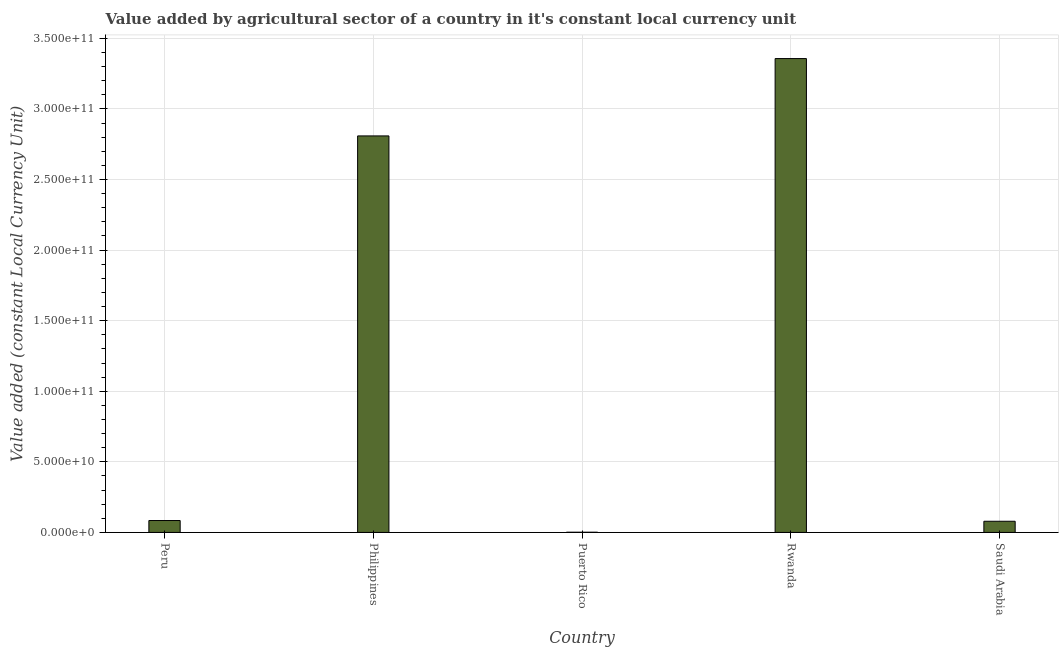Does the graph contain any zero values?
Provide a short and direct response. No. What is the title of the graph?
Your answer should be very brief. Value added by agricultural sector of a country in it's constant local currency unit. What is the label or title of the Y-axis?
Give a very brief answer. Value added (constant Local Currency Unit). What is the value added by agriculture sector in Puerto Rico?
Your answer should be very brief. 1.52e+08. Across all countries, what is the maximum value added by agriculture sector?
Give a very brief answer. 3.36e+11. Across all countries, what is the minimum value added by agriculture sector?
Your response must be concise. 1.52e+08. In which country was the value added by agriculture sector maximum?
Make the answer very short. Rwanda. In which country was the value added by agriculture sector minimum?
Your answer should be very brief. Puerto Rico. What is the sum of the value added by agriculture sector?
Your response must be concise. 6.33e+11. What is the difference between the value added by agriculture sector in Puerto Rico and Saudi Arabia?
Make the answer very short. -7.76e+09. What is the average value added by agriculture sector per country?
Your answer should be compact. 1.27e+11. What is the median value added by agriculture sector?
Your answer should be very brief. 8.44e+09. In how many countries, is the value added by agriculture sector greater than 100000000000 LCU?
Your response must be concise. 2. What is the ratio of the value added by agriculture sector in Philippines to that in Puerto Rico?
Your answer should be very brief. 1842.3. What is the difference between the highest and the second highest value added by agriculture sector?
Provide a short and direct response. 5.48e+1. What is the difference between the highest and the lowest value added by agriculture sector?
Give a very brief answer. 3.35e+11. In how many countries, is the value added by agriculture sector greater than the average value added by agriculture sector taken over all countries?
Offer a terse response. 2. How many countries are there in the graph?
Provide a succinct answer. 5. What is the Value added (constant Local Currency Unit) of Peru?
Your answer should be very brief. 8.44e+09. What is the Value added (constant Local Currency Unit) in Philippines?
Your response must be concise. 2.81e+11. What is the Value added (constant Local Currency Unit) of Puerto Rico?
Your answer should be very brief. 1.52e+08. What is the Value added (constant Local Currency Unit) of Rwanda?
Your response must be concise. 3.36e+11. What is the Value added (constant Local Currency Unit) of Saudi Arabia?
Make the answer very short. 7.91e+09. What is the difference between the Value added (constant Local Currency Unit) in Peru and Philippines?
Your answer should be very brief. -2.72e+11. What is the difference between the Value added (constant Local Currency Unit) in Peru and Puerto Rico?
Ensure brevity in your answer.  8.28e+09. What is the difference between the Value added (constant Local Currency Unit) in Peru and Rwanda?
Offer a very short reply. -3.27e+11. What is the difference between the Value added (constant Local Currency Unit) in Peru and Saudi Arabia?
Your response must be concise. 5.23e+08. What is the difference between the Value added (constant Local Currency Unit) in Philippines and Puerto Rico?
Offer a very short reply. 2.81e+11. What is the difference between the Value added (constant Local Currency Unit) in Philippines and Rwanda?
Your answer should be compact. -5.48e+1. What is the difference between the Value added (constant Local Currency Unit) in Philippines and Saudi Arabia?
Your response must be concise. 2.73e+11. What is the difference between the Value added (constant Local Currency Unit) in Puerto Rico and Rwanda?
Offer a terse response. -3.35e+11. What is the difference between the Value added (constant Local Currency Unit) in Puerto Rico and Saudi Arabia?
Give a very brief answer. -7.76e+09. What is the difference between the Value added (constant Local Currency Unit) in Rwanda and Saudi Arabia?
Your answer should be very brief. 3.28e+11. What is the ratio of the Value added (constant Local Currency Unit) in Peru to that in Philippines?
Ensure brevity in your answer.  0.03. What is the ratio of the Value added (constant Local Currency Unit) in Peru to that in Puerto Rico?
Provide a short and direct response. 55.33. What is the ratio of the Value added (constant Local Currency Unit) in Peru to that in Rwanda?
Your answer should be compact. 0.03. What is the ratio of the Value added (constant Local Currency Unit) in Peru to that in Saudi Arabia?
Offer a terse response. 1.07. What is the ratio of the Value added (constant Local Currency Unit) in Philippines to that in Puerto Rico?
Your response must be concise. 1842.3. What is the ratio of the Value added (constant Local Currency Unit) in Philippines to that in Rwanda?
Your answer should be very brief. 0.84. What is the ratio of the Value added (constant Local Currency Unit) in Philippines to that in Saudi Arabia?
Ensure brevity in your answer.  35.5. What is the ratio of the Value added (constant Local Currency Unit) in Puerto Rico to that in Rwanda?
Give a very brief answer. 0. What is the ratio of the Value added (constant Local Currency Unit) in Puerto Rico to that in Saudi Arabia?
Provide a succinct answer. 0.02. What is the ratio of the Value added (constant Local Currency Unit) in Rwanda to that in Saudi Arabia?
Your response must be concise. 42.42. 